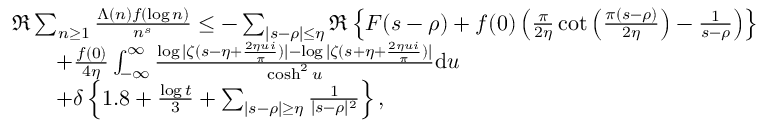Convert formula to latex. <formula><loc_0><loc_0><loc_500><loc_500>\begin{array} { r l } & { \Re \sum _ { n \geq 1 } \frac { \Lambda ( n ) f ( \log n ) } { n ^ { s } } \leq - \sum _ { | s - \rho | \leq \eta } \Re \left \{ F ( s - \rho ) + f ( 0 ) \left ( \frac { \pi } { 2 \eta } \cot \left ( \frac { \pi ( s - \rho ) } { 2 \eta } \right ) - \frac { 1 } { s - \rho } \right ) \right \} } \\ & { \quad + \frac { f ( 0 ) } { 4 \eta } \int _ { - \infty } ^ { \infty } \frac { \log | \zeta ( s - \eta + \frac { 2 \eta u i } { \pi } ) | - \log | \zeta ( s + \eta + \frac { 2 \eta u i } { \pi } ) | } { \cosh ^ { 2 } u } d u } \\ & { \quad + \delta \left \{ 1 . 8 + \frac { \log t } { 3 } + \sum _ { | s - \rho | \geq \eta } \frac { 1 } { | s - \rho | ^ { 2 } } \right \} , } \end{array}</formula> 